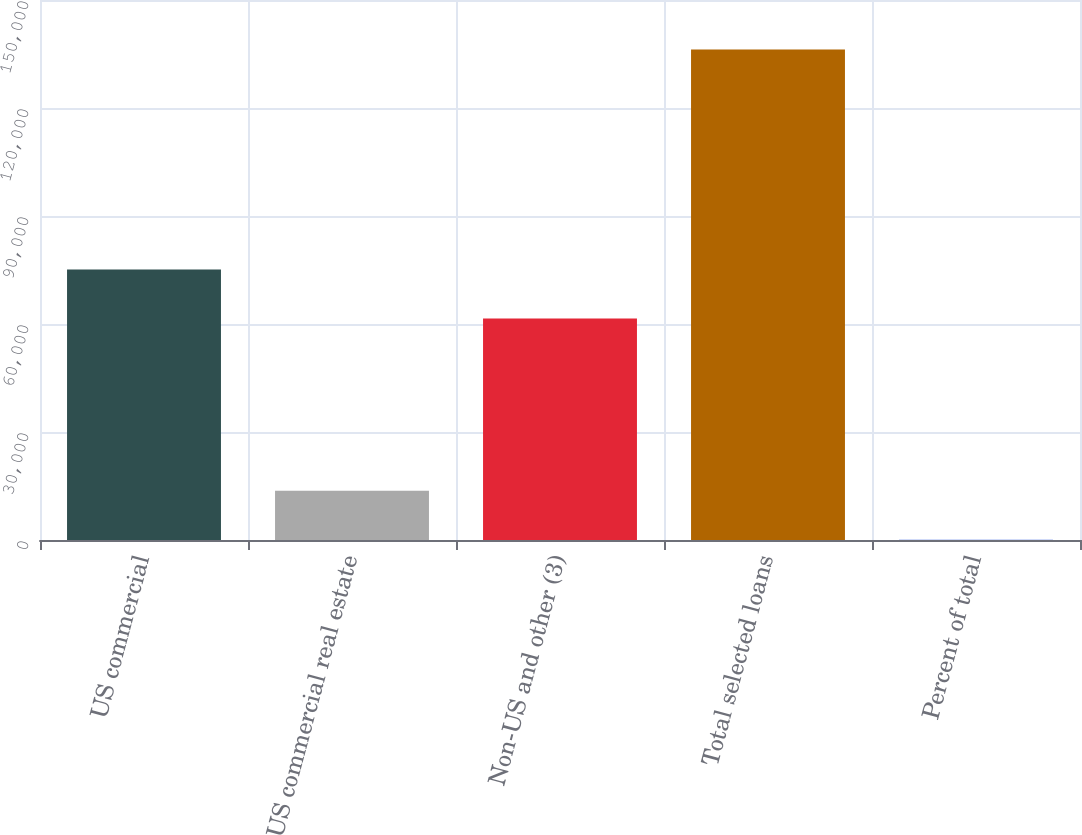<chart> <loc_0><loc_0><loc_500><loc_500><bar_chart><fcel>US commercial<fcel>US commercial real estate<fcel>Non-US and other (3)<fcel>Total selected loans<fcel>Percent of total<nl><fcel>75148<fcel>13661<fcel>61524<fcel>136277<fcel>37<nl></chart> 